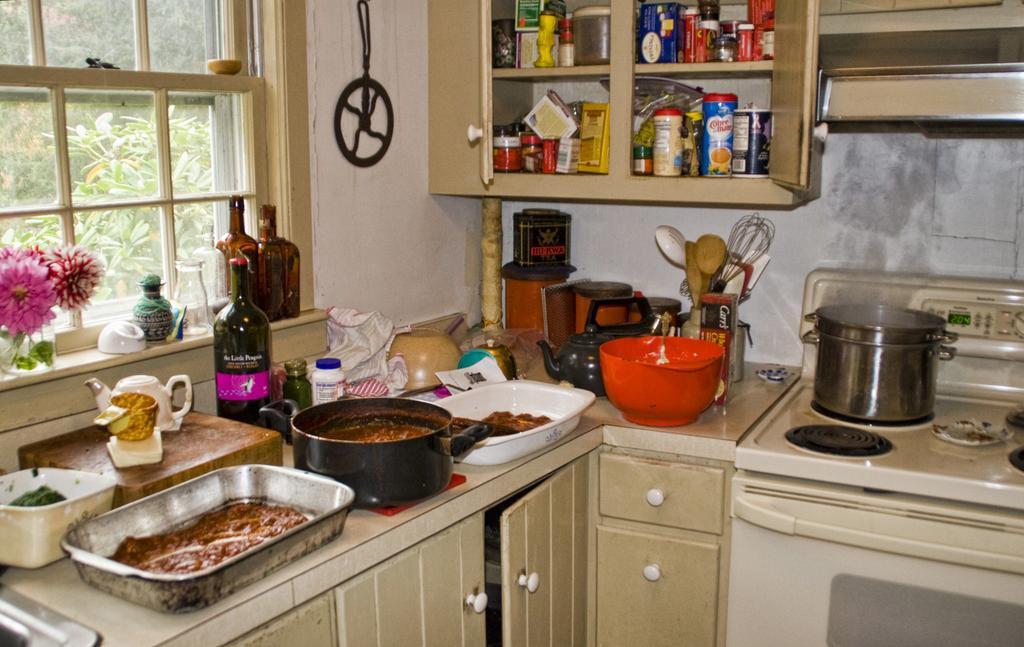Can you describe this image briefly? In this picture we can see bottles, teapots, bowls, trays, jars, flowers, spoons, papers, cupboards, boxes, window, wall, stove and some objects and in the background we can see trees. 